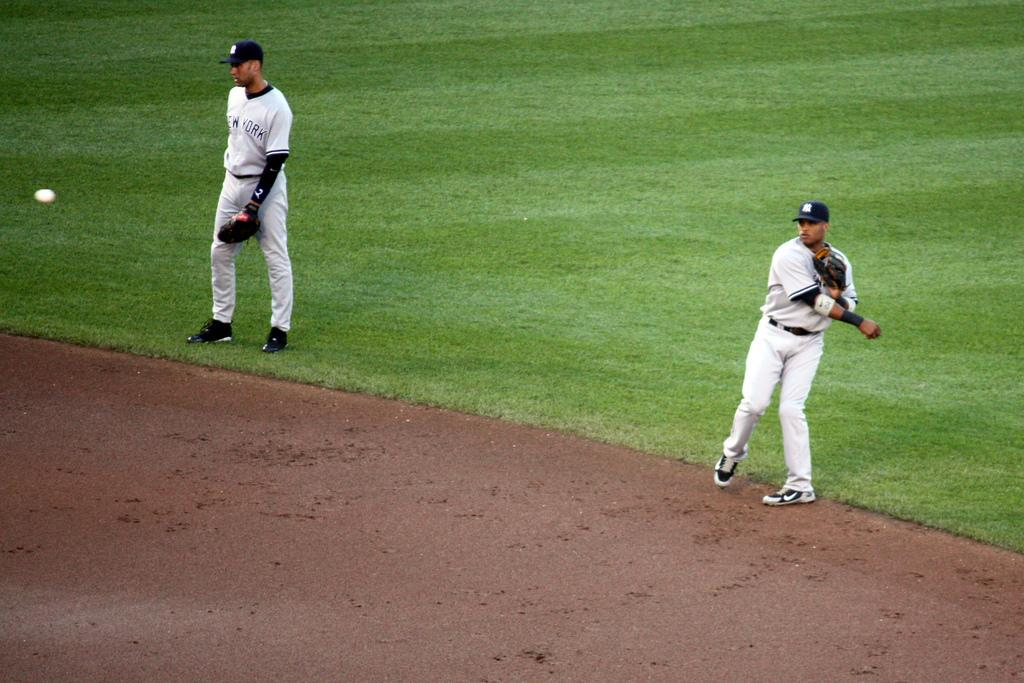How many people are in the image? There are two persons in the foreground of the image. What are the persons doing in the image? The persons are walking on grass. What object can be seen in the image besides the people? There is a ball visible in the image. Where might this image have been taken? The image may have been taken on a field, given the presence of grass. What type of frame is visible around the persons in the image? There is no frame visible around the persons in the image; it is a photograph without any borders. Can you see a pig in the image? No, there is no pig present in the image. 